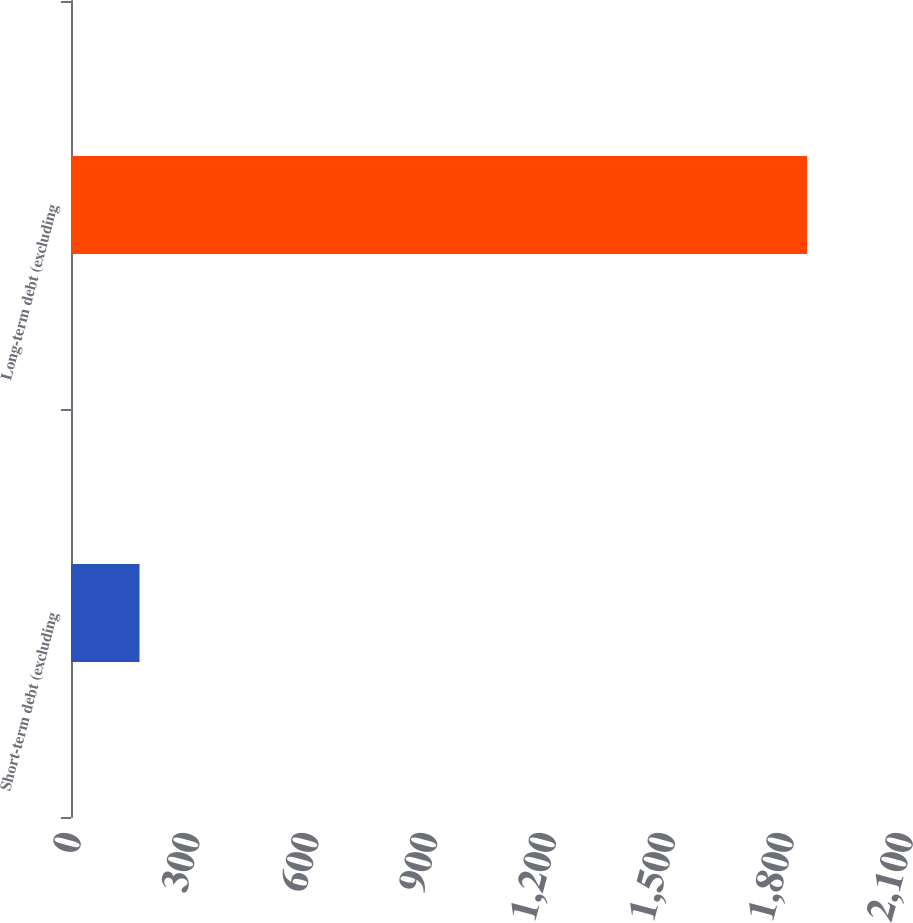Convert chart. <chart><loc_0><loc_0><loc_500><loc_500><bar_chart><fcel>Short-term debt (excluding<fcel>Long-term debt (excluding<nl><fcel>173<fcel>1858<nl></chart> 